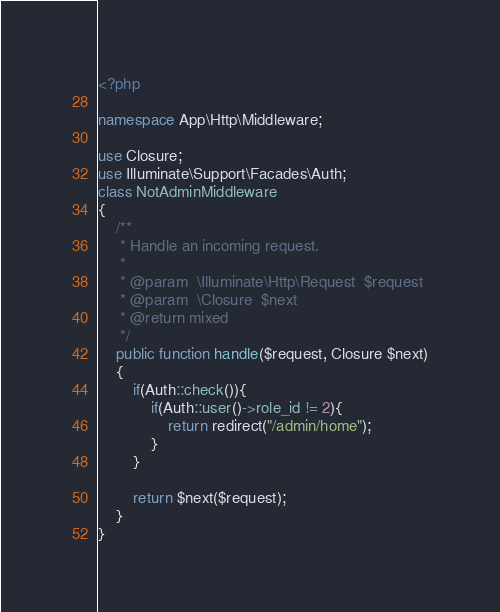Convert code to text. <code><loc_0><loc_0><loc_500><loc_500><_PHP_><?php

namespace App\Http\Middleware;

use Closure;
use Illuminate\Support\Facades\Auth;
class NotAdminMiddleware
{
    /**
     * Handle an incoming request.
     *
     * @param  \Illuminate\Http\Request  $request
     * @param  \Closure  $next
     * @return mixed
     */
    public function handle($request, Closure $next)
    {
        if(Auth::check()){
            if(Auth::user()->role_id != 2){
                return redirect("/admin/home");
            }
        }
        
        return $next($request);
    }
}
</code> 